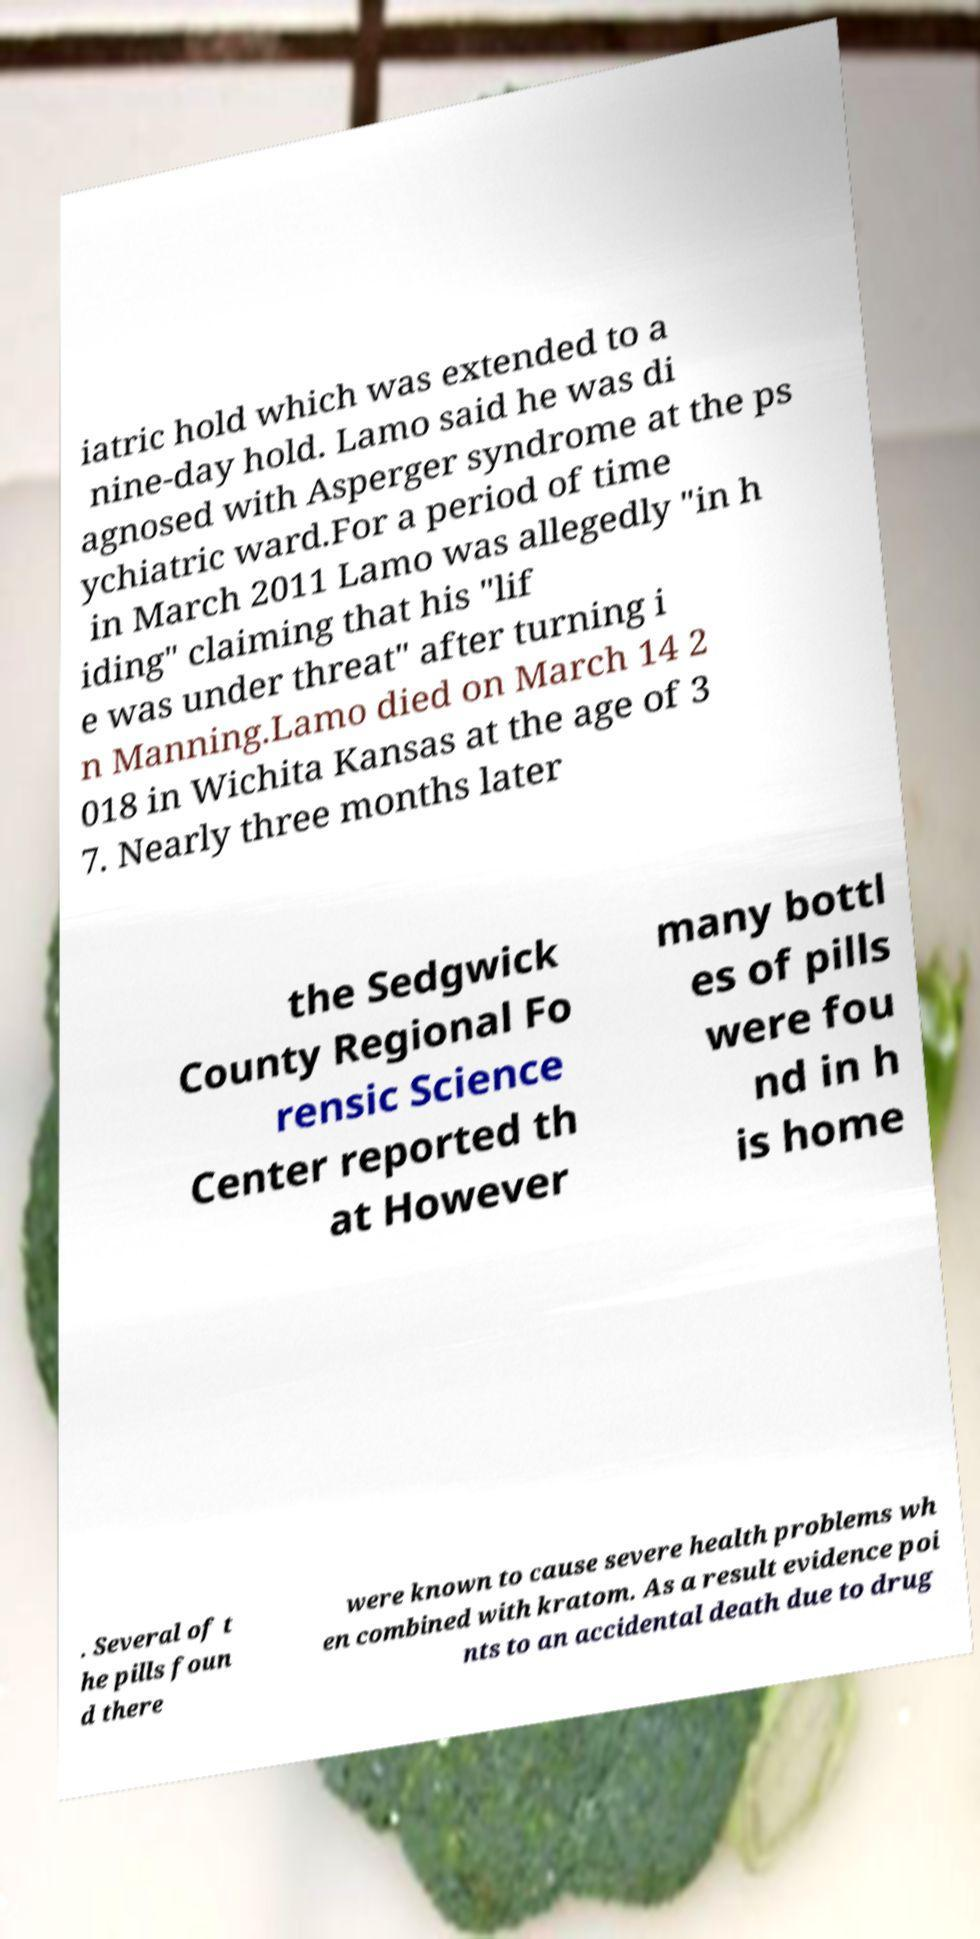Please identify and transcribe the text found in this image. iatric hold which was extended to a nine-day hold. Lamo said he was di agnosed with Asperger syndrome at the ps ychiatric ward.For a period of time in March 2011 Lamo was allegedly "in h iding" claiming that his "lif e was under threat" after turning i n Manning.Lamo died on March 14 2 018 in Wichita Kansas at the age of 3 7. Nearly three months later the Sedgwick County Regional Fo rensic Science Center reported th at However many bottl es of pills were fou nd in h is home . Several of t he pills foun d there were known to cause severe health problems wh en combined with kratom. As a result evidence poi nts to an accidental death due to drug 